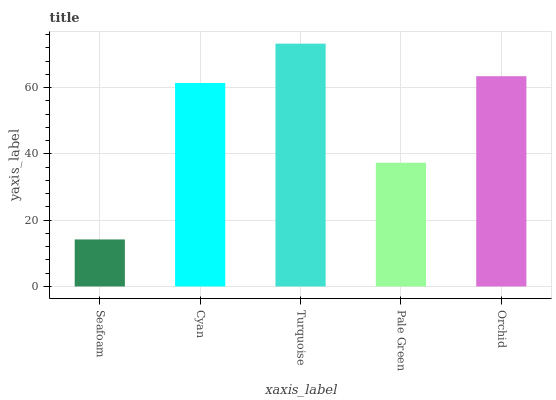Is Seafoam the minimum?
Answer yes or no. Yes. Is Turquoise the maximum?
Answer yes or no. Yes. Is Cyan the minimum?
Answer yes or no. No. Is Cyan the maximum?
Answer yes or no. No. Is Cyan greater than Seafoam?
Answer yes or no. Yes. Is Seafoam less than Cyan?
Answer yes or no. Yes. Is Seafoam greater than Cyan?
Answer yes or no. No. Is Cyan less than Seafoam?
Answer yes or no. No. Is Cyan the high median?
Answer yes or no. Yes. Is Cyan the low median?
Answer yes or no. Yes. Is Turquoise the high median?
Answer yes or no. No. Is Pale Green the low median?
Answer yes or no. No. 